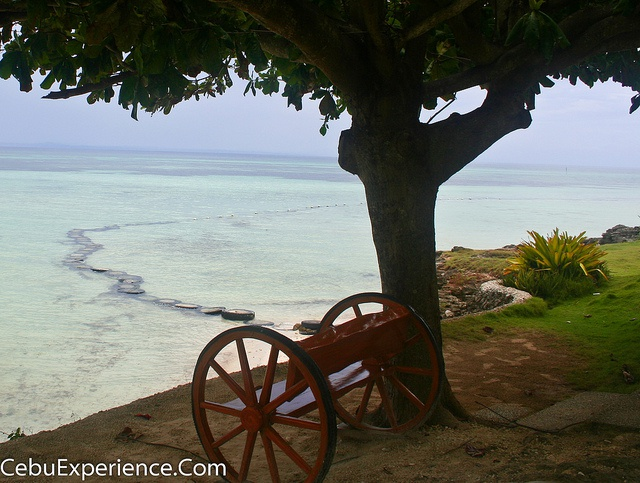Describe the objects in this image and their specific colors. I can see a bench in black, maroon, and lightgray tones in this image. 